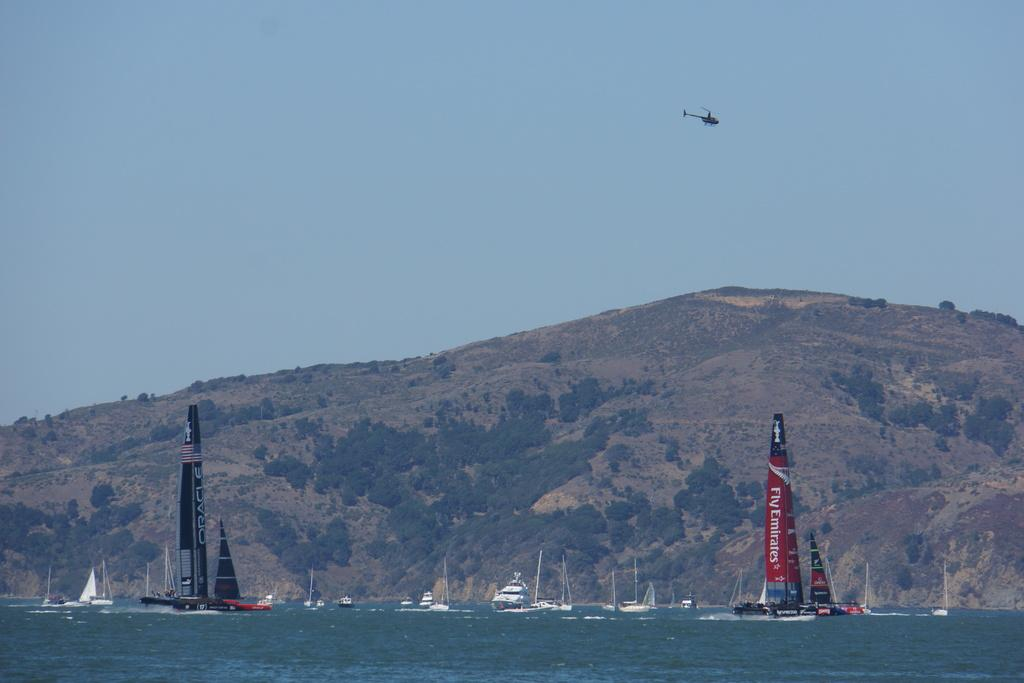<image>
Create a compact narrative representing the image presented. Fly Emirates is displayed on the sail of this vessel. 